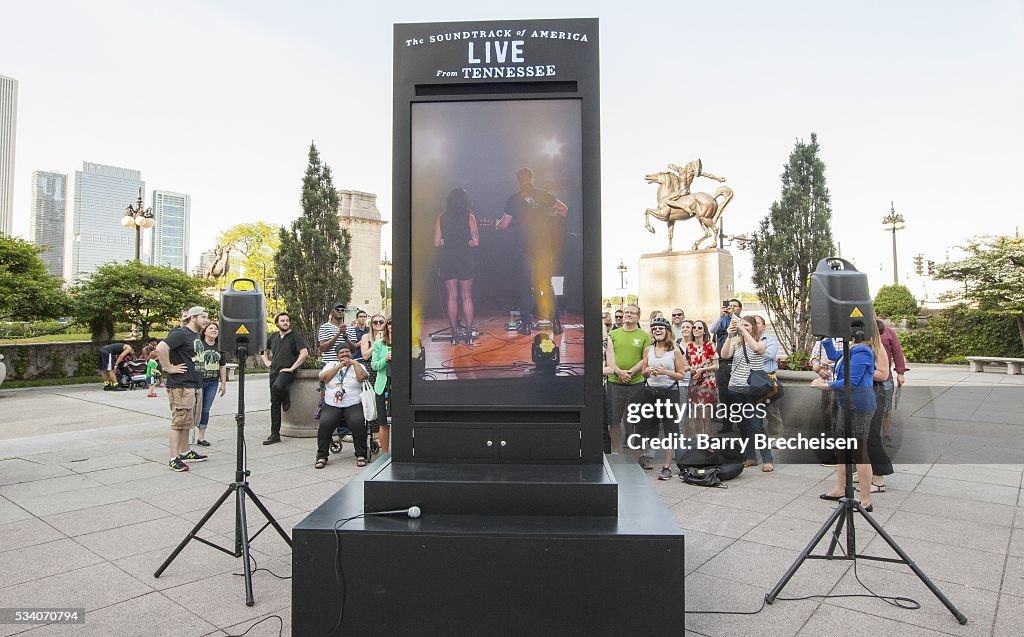Considering the attire of the individuals in the audience, what season might it be, and how does this correlate with the vegetation visible in the background? The individuals in the audience are dressed in light and casual clothing, such as shorts, T-shirts, and airy dresses. This attire indicates warm weather, suggesting the season could be spring or summer. Additionally, the lush green foliage and trees in the background support this inference, as they are fully leafed out and vibrant, which is typical during the warmer months. Therefore, the combination of the audience's attire and the lush vegetation strongly suggests that the event is taking place in spring or summer, seasons known for their pleasant and warm weather. 